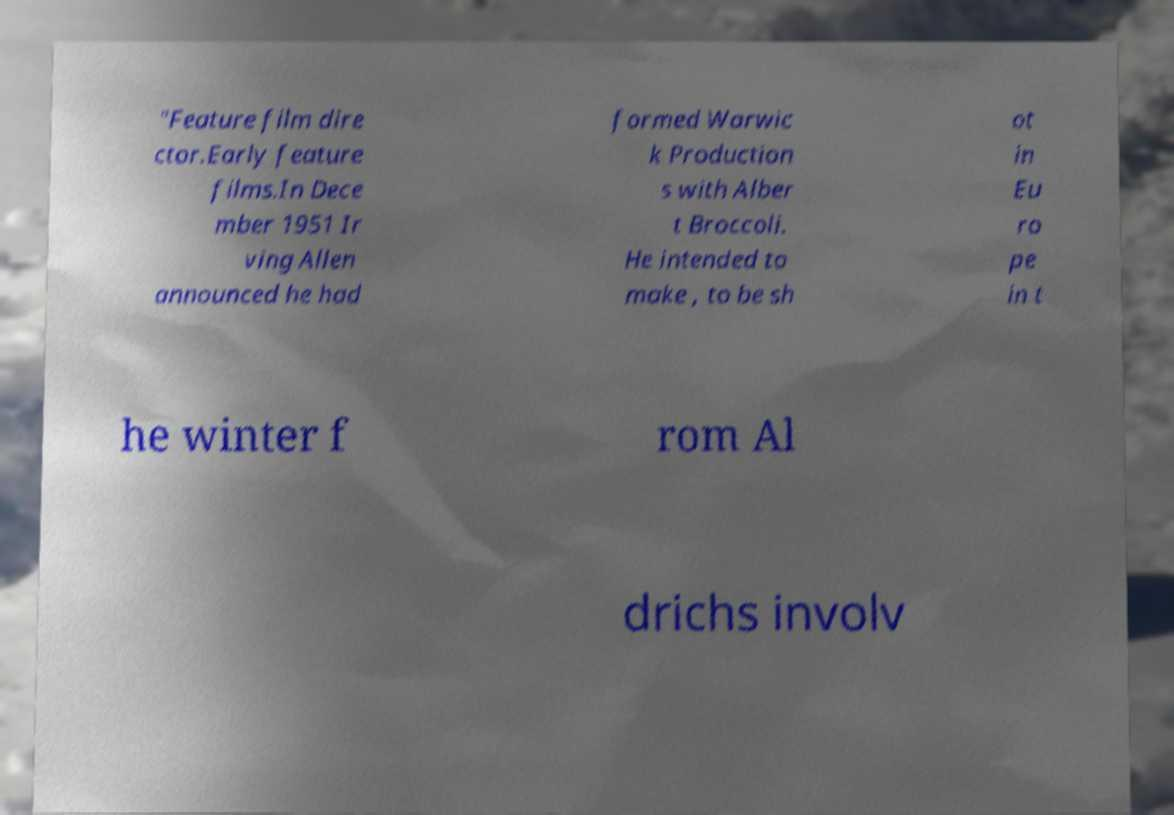I need the written content from this picture converted into text. Can you do that? "Feature film dire ctor.Early feature films.In Dece mber 1951 Ir ving Allen announced he had formed Warwic k Production s with Alber t Broccoli. He intended to make , to be sh ot in Eu ro pe in t he winter f rom Al drichs involv 